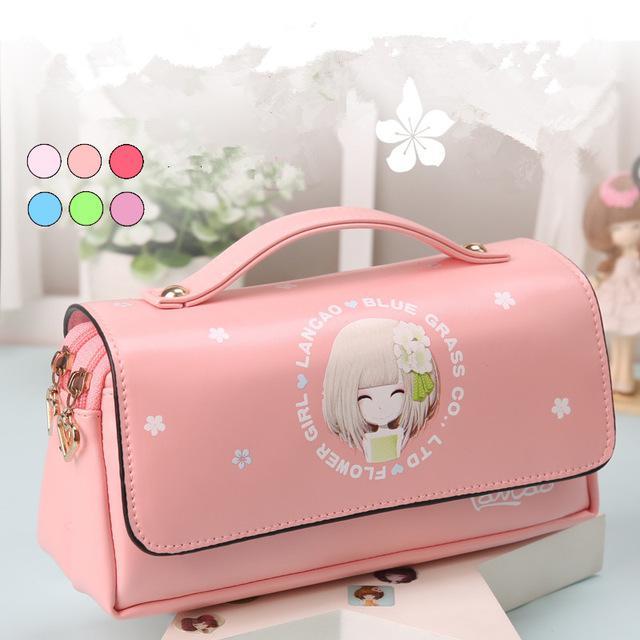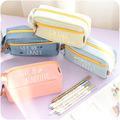The first image is the image on the left, the second image is the image on the right. Evaluate the accuracy of this statement regarding the images: "The left image shows only a single pink case.". Is it true? Answer yes or no. Yes. 